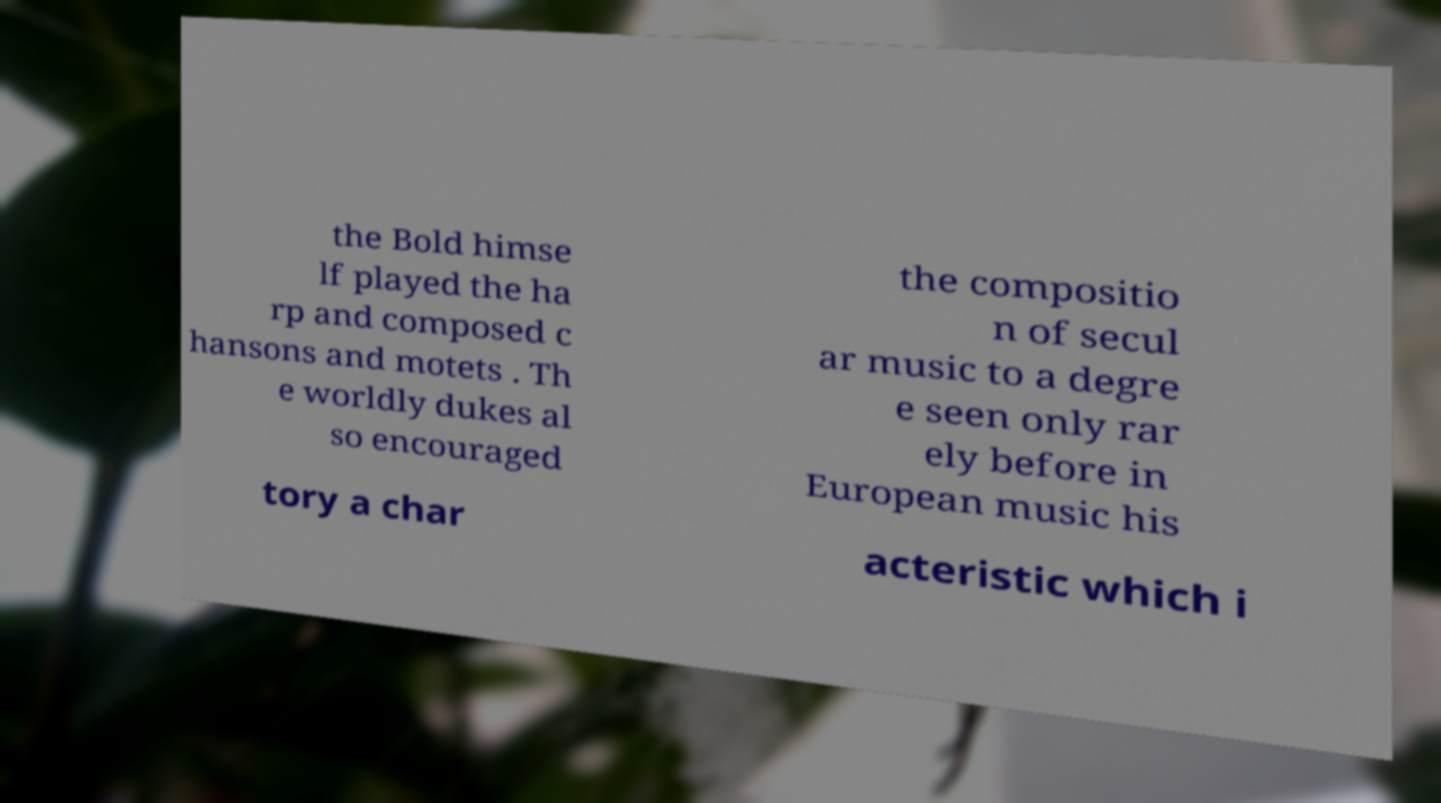What messages or text are displayed in this image? I need them in a readable, typed format. the Bold himse lf played the ha rp and composed c hansons and motets . Th e worldly dukes al so encouraged the compositio n of secul ar music to a degre e seen only rar ely before in European music his tory a char acteristic which i 